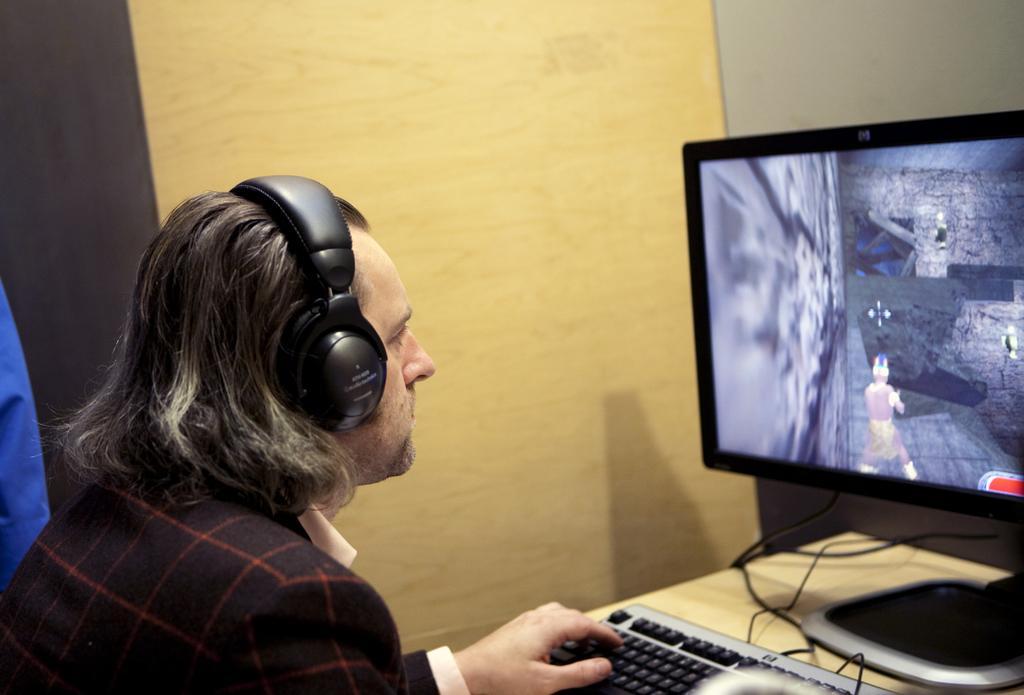How would you summarize this image in a sentence or two? There is a person wearing headphones. In front of him there is a table. On that there is a keyboard and a computer. In the background there is a wall. 